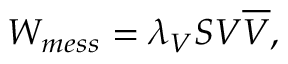Convert formula to latex. <formula><loc_0><loc_0><loc_500><loc_500>W _ { m e s s } = \lambda _ { V } S V { \overline { V } } ,</formula> 